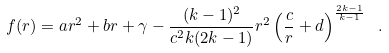<formula> <loc_0><loc_0><loc_500><loc_500>f ( r ) = a r ^ { 2 } + b r + \gamma - \frac { ( k - 1 ) ^ { 2 } } { c ^ { 2 } k ( 2 k - 1 ) } r ^ { 2 } \left ( \frac { c } { r } + d \right ) ^ { \frac { 2 k - 1 } { k - 1 } } \ .</formula> 